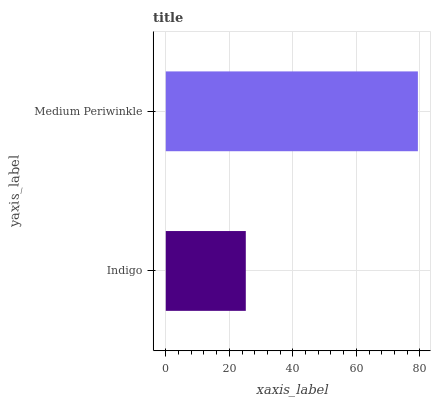Is Indigo the minimum?
Answer yes or no. Yes. Is Medium Periwinkle the maximum?
Answer yes or no. Yes. Is Medium Periwinkle the minimum?
Answer yes or no. No. Is Medium Periwinkle greater than Indigo?
Answer yes or no. Yes. Is Indigo less than Medium Periwinkle?
Answer yes or no. Yes. Is Indigo greater than Medium Periwinkle?
Answer yes or no. No. Is Medium Periwinkle less than Indigo?
Answer yes or no. No. Is Medium Periwinkle the high median?
Answer yes or no. Yes. Is Indigo the low median?
Answer yes or no. Yes. Is Indigo the high median?
Answer yes or no. No. Is Medium Periwinkle the low median?
Answer yes or no. No. 